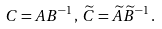Convert formula to latex. <formula><loc_0><loc_0><loc_500><loc_500>C = A B ^ { - 1 } \, , \, \widetilde { C } = \widetilde { A } \widetilde { B } ^ { - 1 } \, .</formula> 